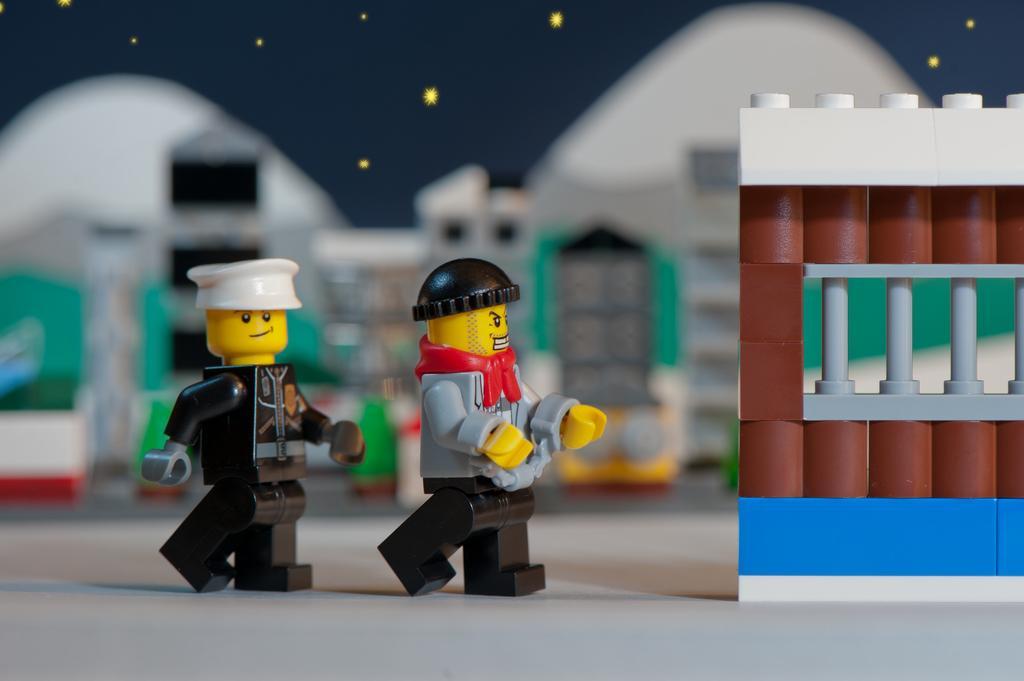Could you give a brief overview of what you see in this image? In this image there are a few toys on the table. There are a few blocks on the table. 